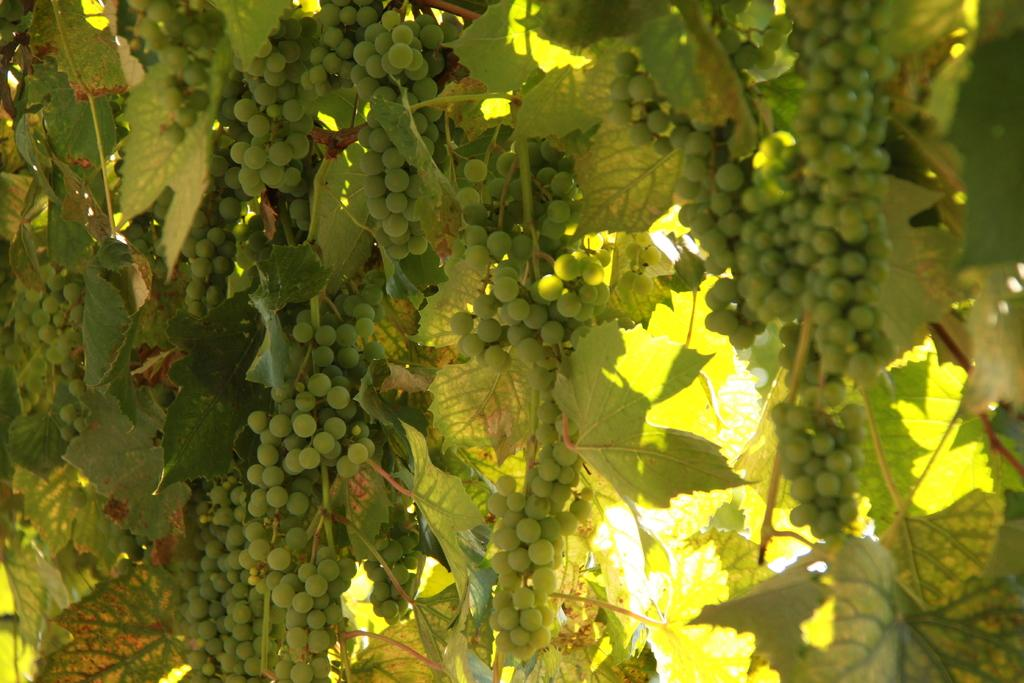What type of plant is in the image? The image contains a plant. What color are the grapes on the plant? The grapes on the plant are green in color. What color are the leaves on the plant? The leaves on the plant are green in color. What color is the background of the image? The background of the image is white in color. What invention is being used to create the shade for the plant in the image? There is no invention or shade present in the image; it only features a plant with green grapes and leaves against a white background. 